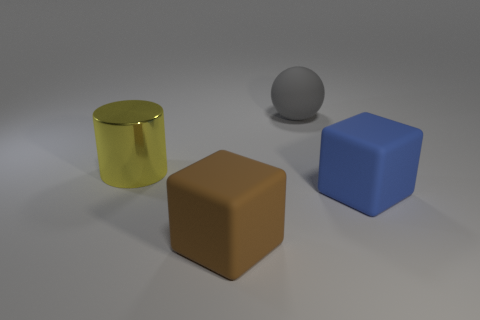Add 4 small blue blocks. How many objects exist? 8 Subtract all balls. How many objects are left? 3 Add 4 big gray spheres. How many big gray spheres exist? 5 Subtract 1 brown blocks. How many objects are left? 3 Subtract all large gray spheres. Subtract all big shiny cylinders. How many objects are left? 2 Add 4 large gray objects. How many large gray objects are left? 5 